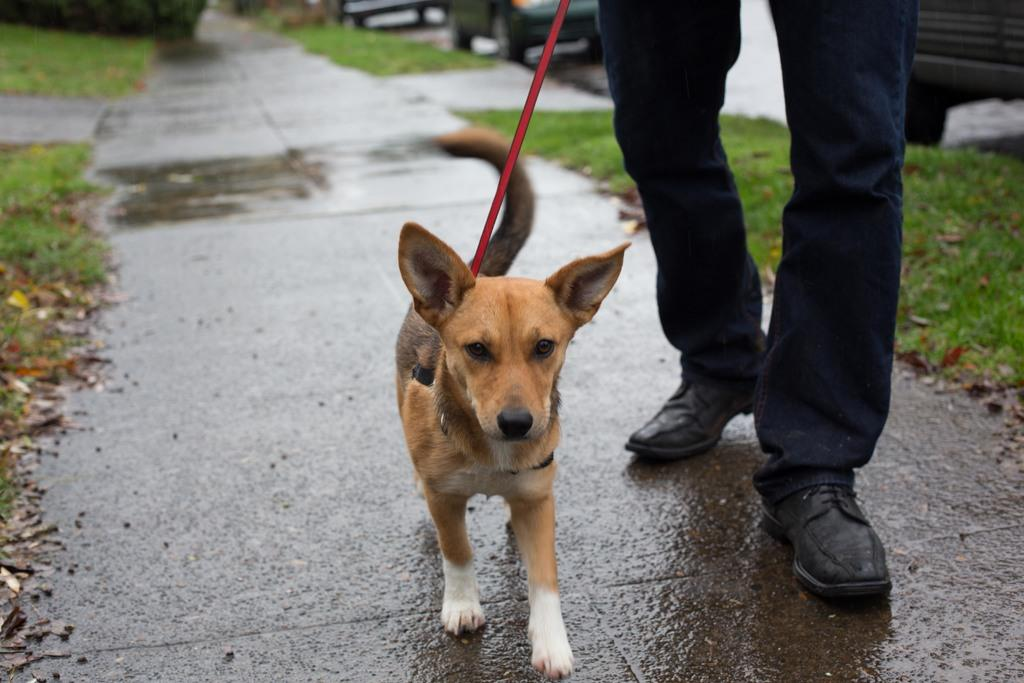What part of a person can be seen in the image? There are legs of a person in the image. What is the dog in the image wearing? There is a dog with a belt in the image. What type of surface is visible in the image? There is a path and grass visible in the image. What type of transportation route is present in the image? There is a road in the image. What can be seen in the background of the image? There are vehicles in the background of the image. Is there a hill visible in the image? There is no hill present in the image. What type of relation does the person have with the dog in the image? The provided facts do not give any information about the relationship between the person and the dog, so it cannot be determined from the image. 